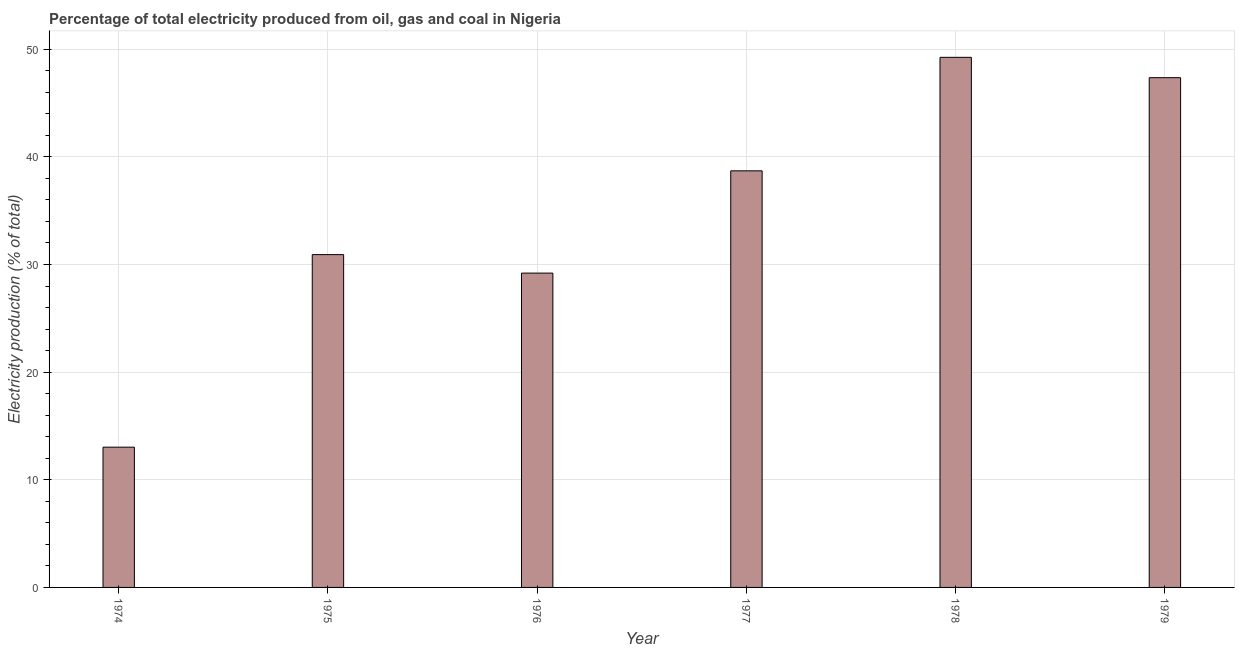What is the title of the graph?
Provide a short and direct response. Percentage of total electricity produced from oil, gas and coal in Nigeria. What is the label or title of the Y-axis?
Your response must be concise. Electricity production (% of total). What is the electricity production in 1978?
Offer a very short reply. 49.25. Across all years, what is the maximum electricity production?
Your response must be concise. 49.25. Across all years, what is the minimum electricity production?
Offer a terse response. 13.03. In which year was the electricity production maximum?
Provide a short and direct response. 1978. In which year was the electricity production minimum?
Your response must be concise. 1974. What is the sum of the electricity production?
Your response must be concise. 208.45. What is the difference between the electricity production in 1974 and 1975?
Keep it short and to the point. -17.89. What is the average electricity production per year?
Your answer should be very brief. 34.74. What is the median electricity production?
Make the answer very short. 34.81. What is the ratio of the electricity production in 1975 to that in 1976?
Your response must be concise. 1.06. Is the electricity production in 1974 less than that in 1978?
Offer a very short reply. Yes. What is the difference between the highest and the second highest electricity production?
Your answer should be very brief. 1.89. What is the difference between the highest and the lowest electricity production?
Provide a short and direct response. 36.22. How many bars are there?
Your answer should be very brief. 6. How many years are there in the graph?
Offer a terse response. 6. Are the values on the major ticks of Y-axis written in scientific E-notation?
Keep it short and to the point. No. What is the Electricity production (% of total) of 1974?
Your answer should be very brief. 13.03. What is the Electricity production (% of total) of 1975?
Make the answer very short. 30.92. What is the Electricity production (% of total) of 1976?
Keep it short and to the point. 29.2. What is the Electricity production (% of total) of 1977?
Give a very brief answer. 38.7. What is the Electricity production (% of total) in 1978?
Keep it short and to the point. 49.25. What is the Electricity production (% of total) of 1979?
Your answer should be very brief. 47.36. What is the difference between the Electricity production (% of total) in 1974 and 1975?
Offer a very short reply. -17.89. What is the difference between the Electricity production (% of total) in 1974 and 1976?
Your answer should be compact. -16.17. What is the difference between the Electricity production (% of total) in 1974 and 1977?
Provide a short and direct response. -25.67. What is the difference between the Electricity production (% of total) in 1974 and 1978?
Your answer should be very brief. -36.22. What is the difference between the Electricity production (% of total) in 1974 and 1979?
Your answer should be very brief. -34.33. What is the difference between the Electricity production (% of total) in 1975 and 1976?
Offer a very short reply. 1.72. What is the difference between the Electricity production (% of total) in 1975 and 1977?
Offer a terse response. -7.78. What is the difference between the Electricity production (% of total) in 1975 and 1978?
Ensure brevity in your answer.  -18.33. What is the difference between the Electricity production (% of total) in 1975 and 1979?
Provide a succinct answer. -16.44. What is the difference between the Electricity production (% of total) in 1976 and 1977?
Provide a succinct answer. -9.5. What is the difference between the Electricity production (% of total) in 1976 and 1978?
Provide a succinct answer. -20.05. What is the difference between the Electricity production (% of total) in 1976 and 1979?
Make the answer very short. -18.15. What is the difference between the Electricity production (% of total) in 1977 and 1978?
Provide a succinct answer. -10.55. What is the difference between the Electricity production (% of total) in 1977 and 1979?
Provide a short and direct response. -8.65. What is the difference between the Electricity production (% of total) in 1978 and 1979?
Keep it short and to the point. 1.89. What is the ratio of the Electricity production (% of total) in 1974 to that in 1975?
Make the answer very short. 0.42. What is the ratio of the Electricity production (% of total) in 1974 to that in 1976?
Provide a succinct answer. 0.45. What is the ratio of the Electricity production (% of total) in 1974 to that in 1977?
Make the answer very short. 0.34. What is the ratio of the Electricity production (% of total) in 1974 to that in 1978?
Your response must be concise. 0.27. What is the ratio of the Electricity production (% of total) in 1974 to that in 1979?
Ensure brevity in your answer.  0.28. What is the ratio of the Electricity production (% of total) in 1975 to that in 1976?
Make the answer very short. 1.06. What is the ratio of the Electricity production (% of total) in 1975 to that in 1977?
Provide a succinct answer. 0.8. What is the ratio of the Electricity production (% of total) in 1975 to that in 1978?
Provide a short and direct response. 0.63. What is the ratio of the Electricity production (% of total) in 1975 to that in 1979?
Your answer should be compact. 0.65. What is the ratio of the Electricity production (% of total) in 1976 to that in 1977?
Make the answer very short. 0.76. What is the ratio of the Electricity production (% of total) in 1976 to that in 1978?
Provide a succinct answer. 0.59. What is the ratio of the Electricity production (% of total) in 1976 to that in 1979?
Ensure brevity in your answer.  0.62. What is the ratio of the Electricity production (% of total) in 1977 to that in 1978?
Offer a terse response. 0.79. What is the ratio of the Electricity production (% of total) in 1977 to that in 1979?
Give a very brief answer. 0.82. What is the ratio of the Electricity production (% of total) in 1978 to that in 1979?
Offer a terse response. 1.04. 